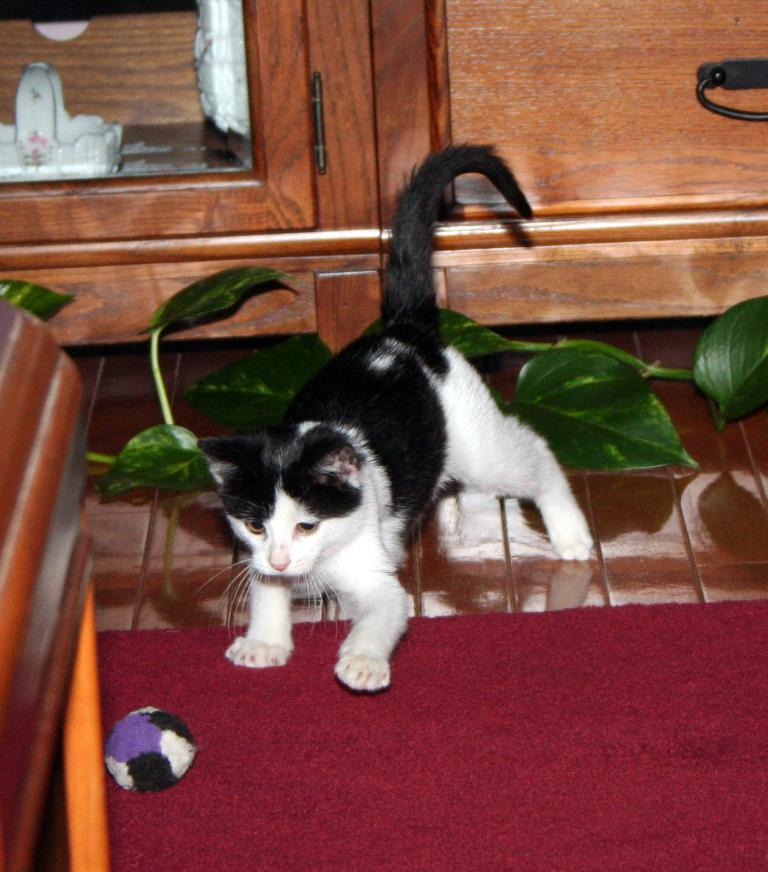What animal can be seen on the ground in the image? There is a cat on the ground in the image. What object is in the foreground of the image? There is a ball in the foreground of the image. What type of vegetation is visible in the background of the image? Leaves on the stem of a plant are visible in the background of the image. What can be seen in the background of the image besides the plant? There are objects in a cupboard in the background of the image. Where is the beggar standing in the image? There is no beggar present in the image. What type of crown can be seen on the cat's head in the image? There is no crown present in the image; the cat does not have any accessories on its head. 